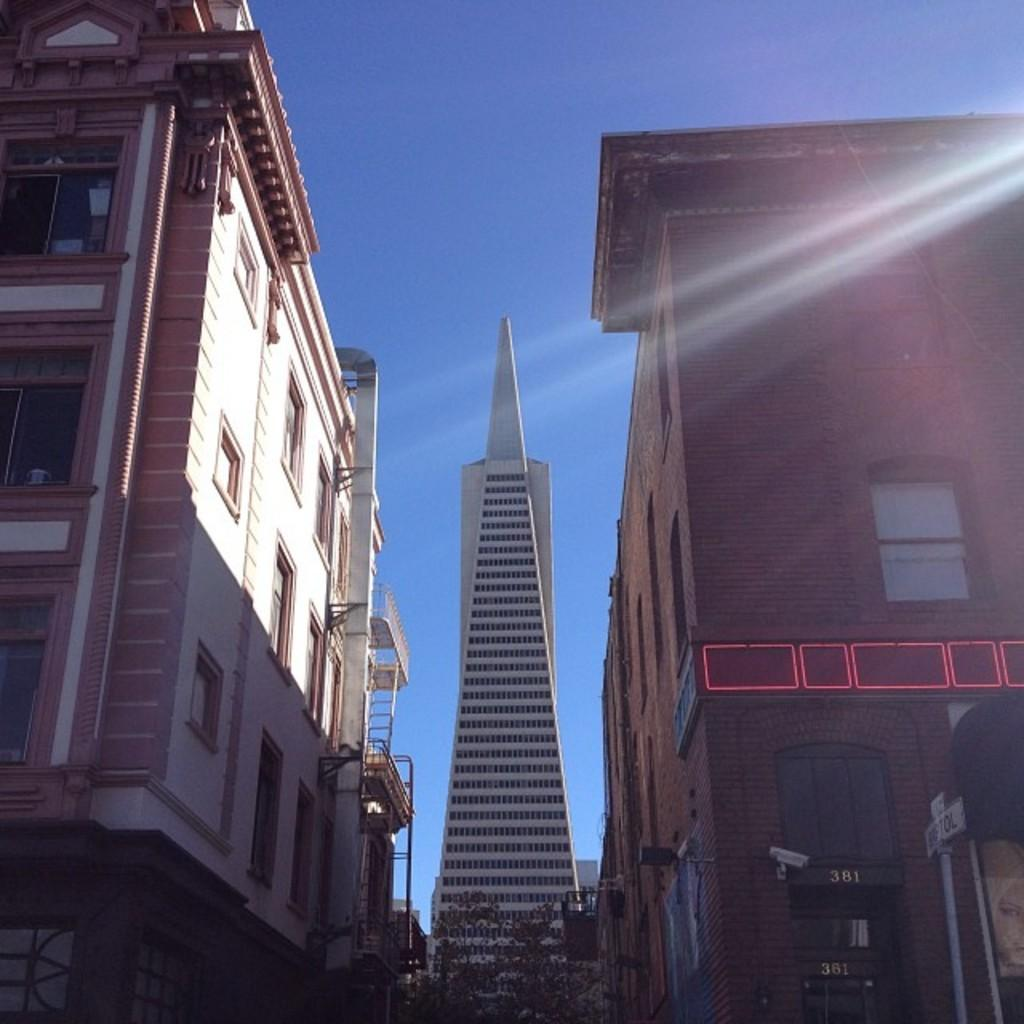What type of structures can be seen in the image? There are buildings in the image. What type of vegetation is at the bottom of the image? There are trees at the bottom of the image. What object is located at the bottom of the image, near the trees? There is a pole at the bottom of the image. What is visible at the top of the image? The sky is visible at the top of the image. How many oranges are hanging from the trees in the image? There are no oranges present in the image; it features trees and a pole. What does the mom say about the buildings in the image? There is no mention of a mom or any dialogue in the image, so it is not possible to answer that question. 